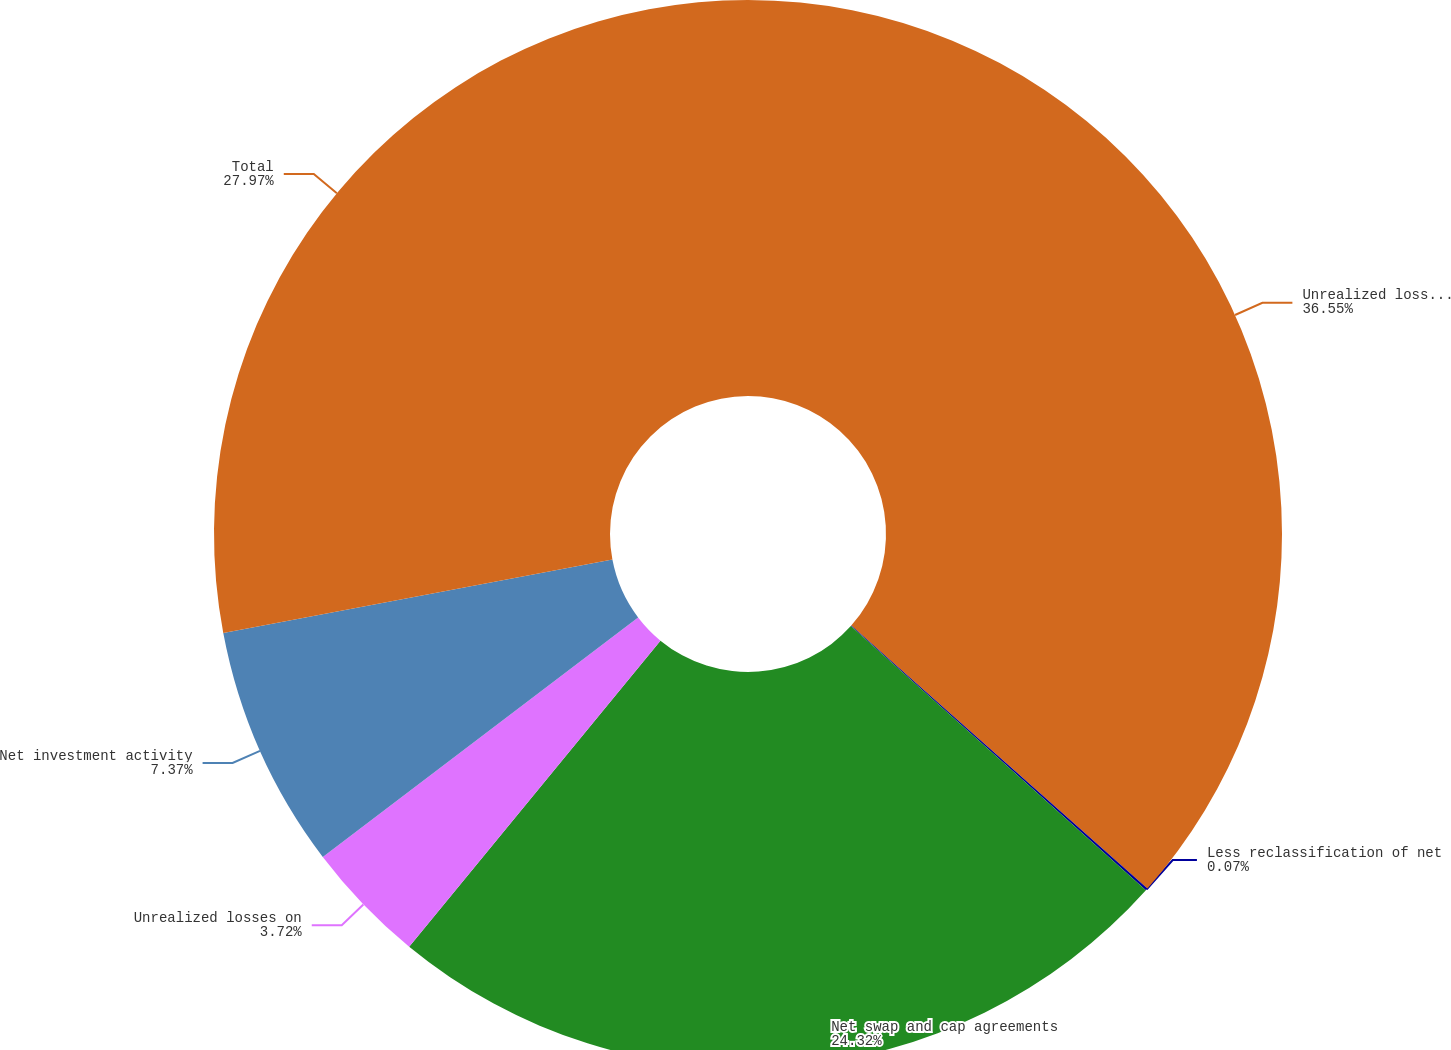Convert chart. <chart><loc_0><loc_0><loc_500><loc_500><pie_chart><fcel>Unrealized losses on interest<fcel>Less reclassification of net<fcel>Net swap and cap agreements<fcel>Unrealized losses on<fcel>Net investment activity<fcel>Total<nl><fcel>36.55%<fcel>0.07%<fcel>24.32%<fcel>3.72%<fcel>7.37%<fcel>27.97%<nl></chart> 